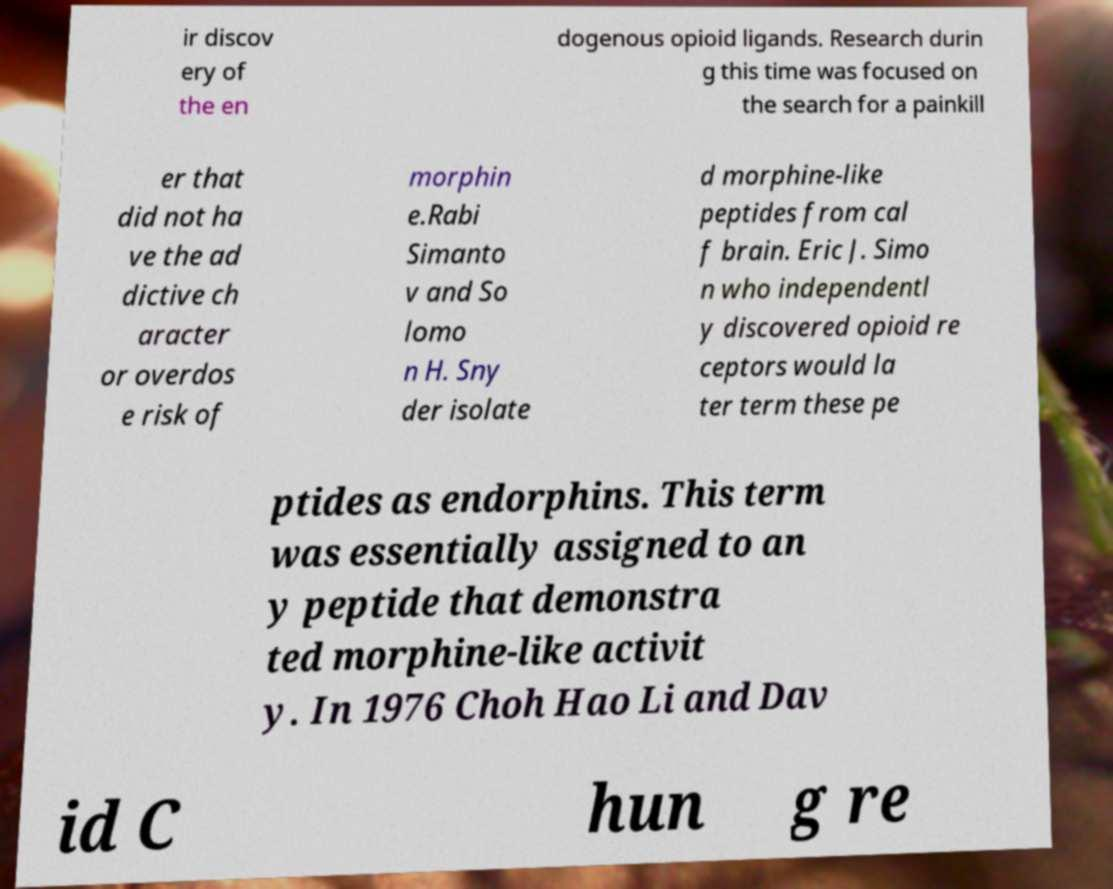Please identify and transcribe the text found in this image. ir discov ery of the en dogenous opioid ligands. Research durin g this time was focused on the search for a painkill er that did not ha ve the ad dictive ch aracter or overdos e risk of morphin e.Rabi Simanto v and So lomo n H. Sny der isolate d morphine-like peptides from cal f brain. Eric J. Simo n who independentl y discovered opioid re ceptors would la ter term these pe ptides as endorphins. This term was essentially assigned to an y peptide that demonstra ted morphine-like activit y. In 1976 Choh Hao Li and Dav id C hun g re 